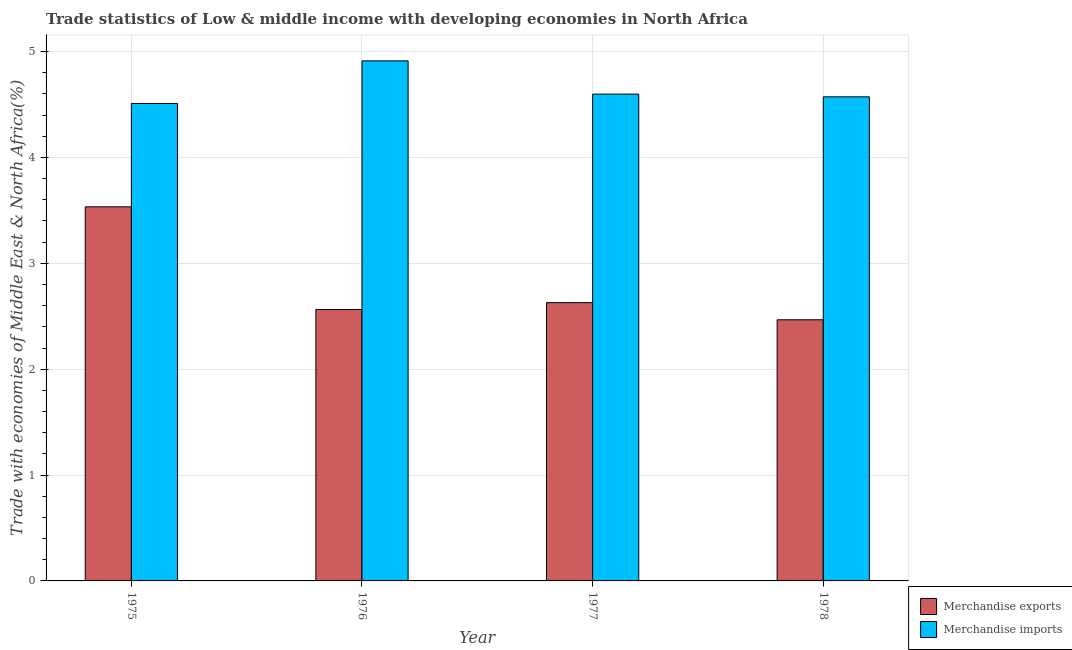How many different coloured bars are there?
Provide a succinct answer. 2. Are the number of bars per tick equal to the number of legend labels?
Your answer should be very brief. Yes. How many bars are there on the 1st tick from the left?
Provide a short and direct response. 2. What is the label of the 1st group of bars from the left?
Provide a short and direct response. 1975. In how many cases, is the number of bars for a given year not equal to the number of legend labels?
Your answer should be compact. 0. What is the merchandise exports in 1977?
Provide a short and direct response. 2.63. Across all years, what is the maximum merchandise imports?
Offer a terse response. 4.91. Across all years, what is the minimum merchandise exports?
Offer a very short reply. 2.47. In which year was the merchandise imports maximum?
Ensure brevity in your answer.  1976. In which year was the merchandise imports minimum?
Make the answer very short. 1975. What is the total merchandise imports in the graph?
Keep it short and to the point. 18.59. What is the difference between the merchandise exports in 1977 and that in 1978?
Provide a short and direct response. 0.16. What is the difference between the merchandise exports in 1975 and the merchandise imports in 1978?
Offer a very short reply. 1.07. What is the average merchandise exports per year?
Your answer should be very brief. 2.8. In the year 1978, what is the difference between the merchandise imports and merchandise exports?
Ensure brevity in your answer.  0. In how many years, is the merchandise imports greater than 2.2 %?
Give a very brief answer. 4. What is the ratio of the merchandise imports in 1976 to that in 1978?
Your answer should be compact. 1.07. Is the difference between the merchandise imports in 1977 and 1978 greater than the difference between the merchandise exports in 1977 and 1978?
Your response must be concise. No. What is the difference between the highest and the second highest merchandise imports?
Give a very brief answer. 0.31. What is the difference between the highest and the lowest merchandise exports?
Keep it short and to the point. 1.07. What does the 2nd bar from the left in 1978 represents?
Ensure brevity in your answer.  Merchandise imports. How many years are there in the graph?
Provide a short and direct response. 4. What is the difference between two consecutive major ticks on the Y-axis?
Give a very brief answer. 1. Does the graph contain any zero values?
Make the answer very short. No. How are the legend labels stacked?
Provide a succinct answer. Vertical. What is the title of the graph?
Your answer should be very brief. Trade statistics of Low & middle income with developing economies in North Africa. What is the label or title of the Y-axis?
Your answer should be very brief. Trade with economies of Middle East & North Africa(%). What is the Trade with economies of Middle East & North Africa(%) in Merchandise exports in 1975?
Provide a succinct answer. 3.53. What is the Trade with economies of Middle East & North Africa(%) in Merchandise imports in 1975?
Your answer should be very brief. 4.51. What is the Trade with economies of Middle East & North Africa(%) of Merchandise exports in 1976?
Keep it short and to the point. 2.56. What is the Trade with economies of Middle East & North Africa(%) of Merchandise imports in 1976?
Provide a short and direct response. 4.91. What is the Trade with economies of Middle East & North Africa(%) of Merchandise exports in 1977?
Your answer should be very brief. 2.63. What is the Trade with economies of Middle East & North Africa(%) of Merchandise imports in 1977?
Your response must be concise. 4.6. What is the Trade with economies of Middle East & North Africa(%) of Merchandise exports in 1978?
Provide a succinct answer. 2.47. What is the Trade with economies of Middle East & North Africa(%) in Merchandise imports in 1978?
Make the answer very short. 4.57. Across all years, what is the maximum Trade with economies of Middle East & North Africa(%) of Merchandise exports?
Ensure brevity in your answer.  3.53. Across all years, what is the maximum Trade with economies of Middle East & North Africa(%) of Merchandise imports?
Your response must be concise. 4.91. Across all years, what is the minimum Trade with economies of Middle East & North Africa(%) of Merchandise exports?
Provide a short and direct response. 2.47. Across all years, what is the minimum Trade with economies of Middle East & North Africa(%) of Merchandise imports?
Offer a very short reply. 4.51. What is the total Trade with economies of Middle East & North Africa(%) in Merchandise exports in the graph?
Your answer should be compact. 11.19. What is the total Trade with economies of Middle East & North Africa(%) in Merchandise imports in the graph?
Ensure brevity in your answer.  18.59. What is the difference between the Trade with economies of Middle East & North Africa(%) of Merchandise exports in 1975 and that in 1976?
Your answer should be very brief. 0.97. What is the difference between the Trade with economies of Middle East & North Africa(%) of Merchandise imports in 1975 and that in 1976?
Give a very brief answer. -0.4. What is the difference between the Trade with economies of Middle East & North Africa(%) in Merchandise exports in 1975 and that in 1977?
Your answer should be compact. 0.91. What is the difference between the Trade with economies of Middle East & North Africa(%) in Merchandise imports in 1975 and that in 1977?
Provide a short and direct response. -0.09. What is the difference between the Trade with economies of Middle East & North Africa(%) in Merchandise exports in 1975 and that in 1978?
Offer a terse response. 1.07. What is the difference between the Trade with economies of Middle East & North Africa(%) in Merchandise imports in 1975 and that in 1978?
Offer a terse response. -0.06. What is the difference between the Trade with economies of Middle East & North Africa(%) in Merchandise exports in 1976 and that in 1977?
Keep it short and to the point. -0.06. What is the difference between the Trade with economies of Middle East & North Africa(%) of Merchandise imports in 1976 and that in 1977?
Provide a succinct answer. 0.31. What is the difference between the Trade with economies of Middle East & North Africa(%) in Merchandise exports in 1976 and that in 1978?
Make the answer very short. 0.1. What is the difference between the Trade with economies of Middle East & North Africa(%) of Merchandise imports in 1976 and that in 1978?
Offer a very short reply. 0.34. What is the difference between the Trade with economies of Middle East & North Africa(%) of Merchandise exports in 1977 and that in 1978?
Provide a succinct answer. 0.16. What is the difference between the Trade with economies of Middle East & North Africa(%) of Merchandise imports in 1977 and that in 1978?
Your response must be concise. 0.03. What is the difference between the Trade with economies of Middle East & North Africa(%) in Merchandise exports in 1975 and the Trade with economies of Middle East & North Africa(%) in Merchandise imports in 1976?
Provide a short and direct response. -1.38. What is the difference between the Trade with economies of Middle East & North Africa(%) in Merchandise exports in 1975 and the Trade with economies of Middle East & North Africa(%) in Merchandise imports in 1977?
Your answer should be compact. -1.06. What is the difference between the Trade with economies of Middle East & North Africa(%) in Merchandise exports in 1975 and the Trade with economies of Middle East & North Africa(%) in Merchandise imports in 1978?
Offer a very short reply. -1.04. What is the difference between the Trade with economies of Middle East & North Africa(%) of Merchandise exports in 1976 and the Trade with economies of Middle East & North Africa(%) of Merchandise imports in 1977?
Offer a terse response. -2.03. What is the difference between the Trade with economies of Middle East & North Africa(%) in Merchandise exports in 1976 and the Trade with economies of Middle East & North Africa(%) in Merchandise imports in 1978?
Offer a terse response. -2.01. What is the difference between the Trade with economies of Middle East & North Africa(%) of Merchandise exports in 1977 and the Trade with economies of Middle East & North Africa(%) of Merchandise imports in 1978?
Offer a very short reply. -1.94. What is the average Trade with economies of Middle East & North Africa(%) of Merchandise exports per year?
Offer a terse response. 2.8. What is the average Trade with economies of Middle East & North Africa(%) of Merchandise imports per year?
Provide a succinct answer. 4.65. In the year 1975, what is the difference between the Trade with economies of Middle East & North Africa(%) of Merchandise exports and Trade with economies of Middle East & North Africa(%) of Merchandise imports?
Ensure brevity in your answer.  -0.98. In the year 1976, what is the difference between the Trade with economies of Middle East & North Africa(%) in Merchandise exports and Trade with economies of Middle East & North Africa(%) in Merchandise imports?
Your answer should be compact. -2.35. In the year 1977, what is the difference between the Trade with economies of Middle East & North Africa(%) of Merchandise exports and Trade with economies of Middle East & North Africa(%) of Merchandise imports?
Keep it short and to the point. -1.97. In the year 1978, what is the difference between the Trade with economies of Middle East & North Africa(%) in Merchandise exports and Trade with economies of Middle East & North Africa(%) in Merchandise imports?
Provide a short and direct response. -2.11. What is the ratio of the Trade with economies of Middle East & North Africa(%) in Merchandise exports in 1975 to that in 1976?
Offer a terse response. 1.38. What is the ratio of the Trade with economies of Middle East & North Africa(%) of Merchandise imports in 1975 to that in 1976?
Ensure brevity in your answer.  0.92. What is the ratio of the Trade with economies of Middle East & North Africa(%) in Merchandise exports in 1975 to that in 1977?
Give a very brief answer. 1.34. What is the ratio of the Trade with economies of Middle East & North Africa(%) in Merchandise imports in 1975 to that in 1977?
Your answer should be compact. 0.98. What is the ratio of the Trade with economies of Middle East & North Africa(%) of Merchandise exports in 1975 to that in 1978?
Your answer should be very brief. 1.43. What is the ratio of the Trade with economies of Middle East & North Africa(%) of Merchandise imports in 1975 to that in 1978?
Ensure brevity in your answer.  0.99. What is the ratio of the Trade with economies of Middle East & North Africa(%) of Merchandise exports in 1976 to that in 1977?
Give a very brief answer. 0.98. What is the ratio of the Trade with economies of Middle East & North Africa(%) in Merchandise imports in 1976 to that in 1977?
Your answer should be compact. 1.07. What is the ratio of the Trade with economies of Middle East & North Africa(%) of Merchandise exports in 1976 to that in 1978?
Make the answer very short. 1.04. What is the ratio of the Trade with economies of Middle East & North Africa(%) of Merchandise imports in 1976 to that in 1978?
Offer a very short reply. 1.07. What is the ratio of the Trade with economies of Middle East & North Africa(%) of Merchandise exports in 1977 to that in 1978?
Provide a short and direct response. 1.07. What is the ratio of the Trade with economies of Middle East & North Africa(%) of Merchandise imports in 1977 to that in 1978?
Offer a terse response. 1.01. What is the difference between the highest and the second highest Trade with economies of Middle East & North Africa(%) in Merchandise exports?
Ensure brevity in your answer.  0.91. What is the difference between the highest and the second highest Trade with economies of Middle East & North Africa(%) of Merchandise imports?
Your answer should be compact. 0.31. What is the difference between the highest and the lowest Trade with economies of Middle East & North Africa(%) in Merchandise exports?
Ensure brevity in your answer.  1.07. What is the difference between the highest and the lowest Trade with economies of Middle East & North Africa(%) in Merchandise imports?
Offer a very short reply. 0.4. 